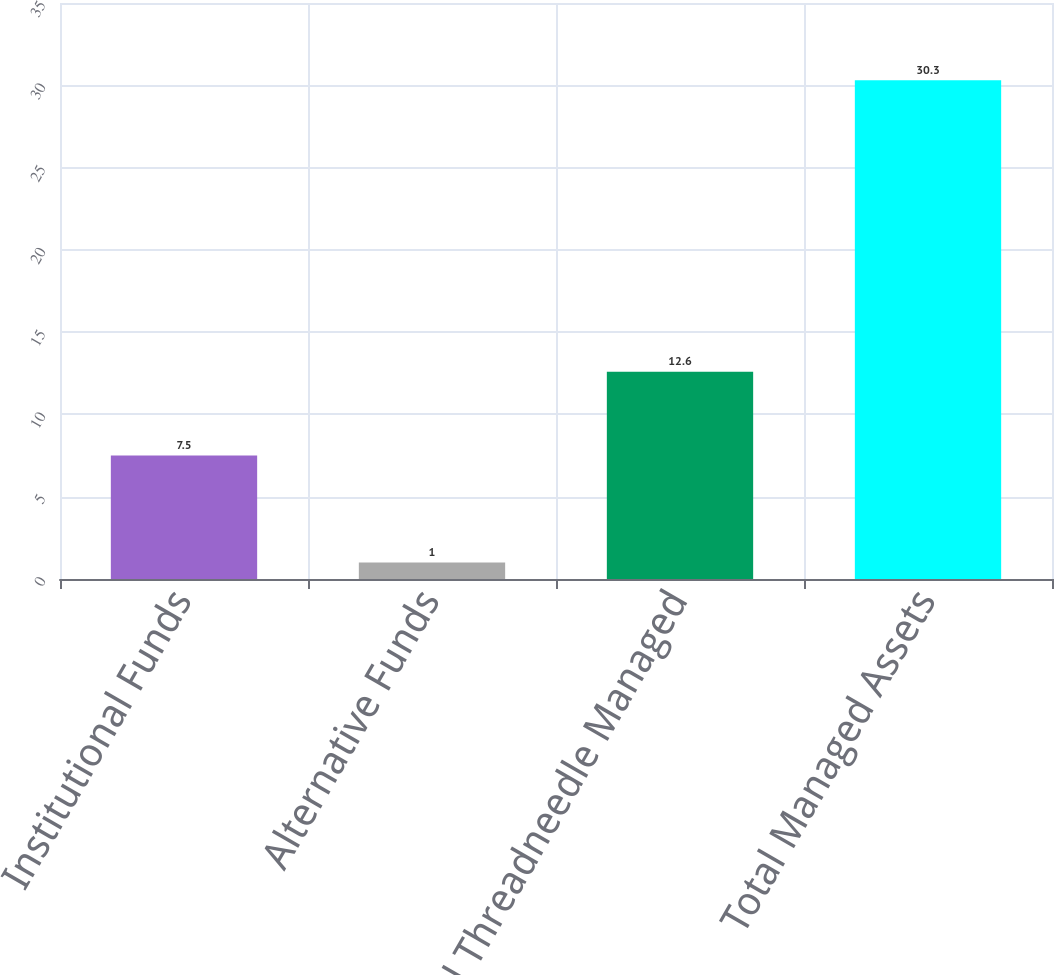Convert chart to OTSL. <chart><loc_0><loc_0><loc_500><loc_500><bar_chart><fcel>Institutional Funds<fcel>Alternative Funds<fcel>Total Threadneedle Managed<fcel>Total Managed Assets<nl><fcel>7.5<fcel>1<fcel>12.6<fcel>30.3<nl></chart> 